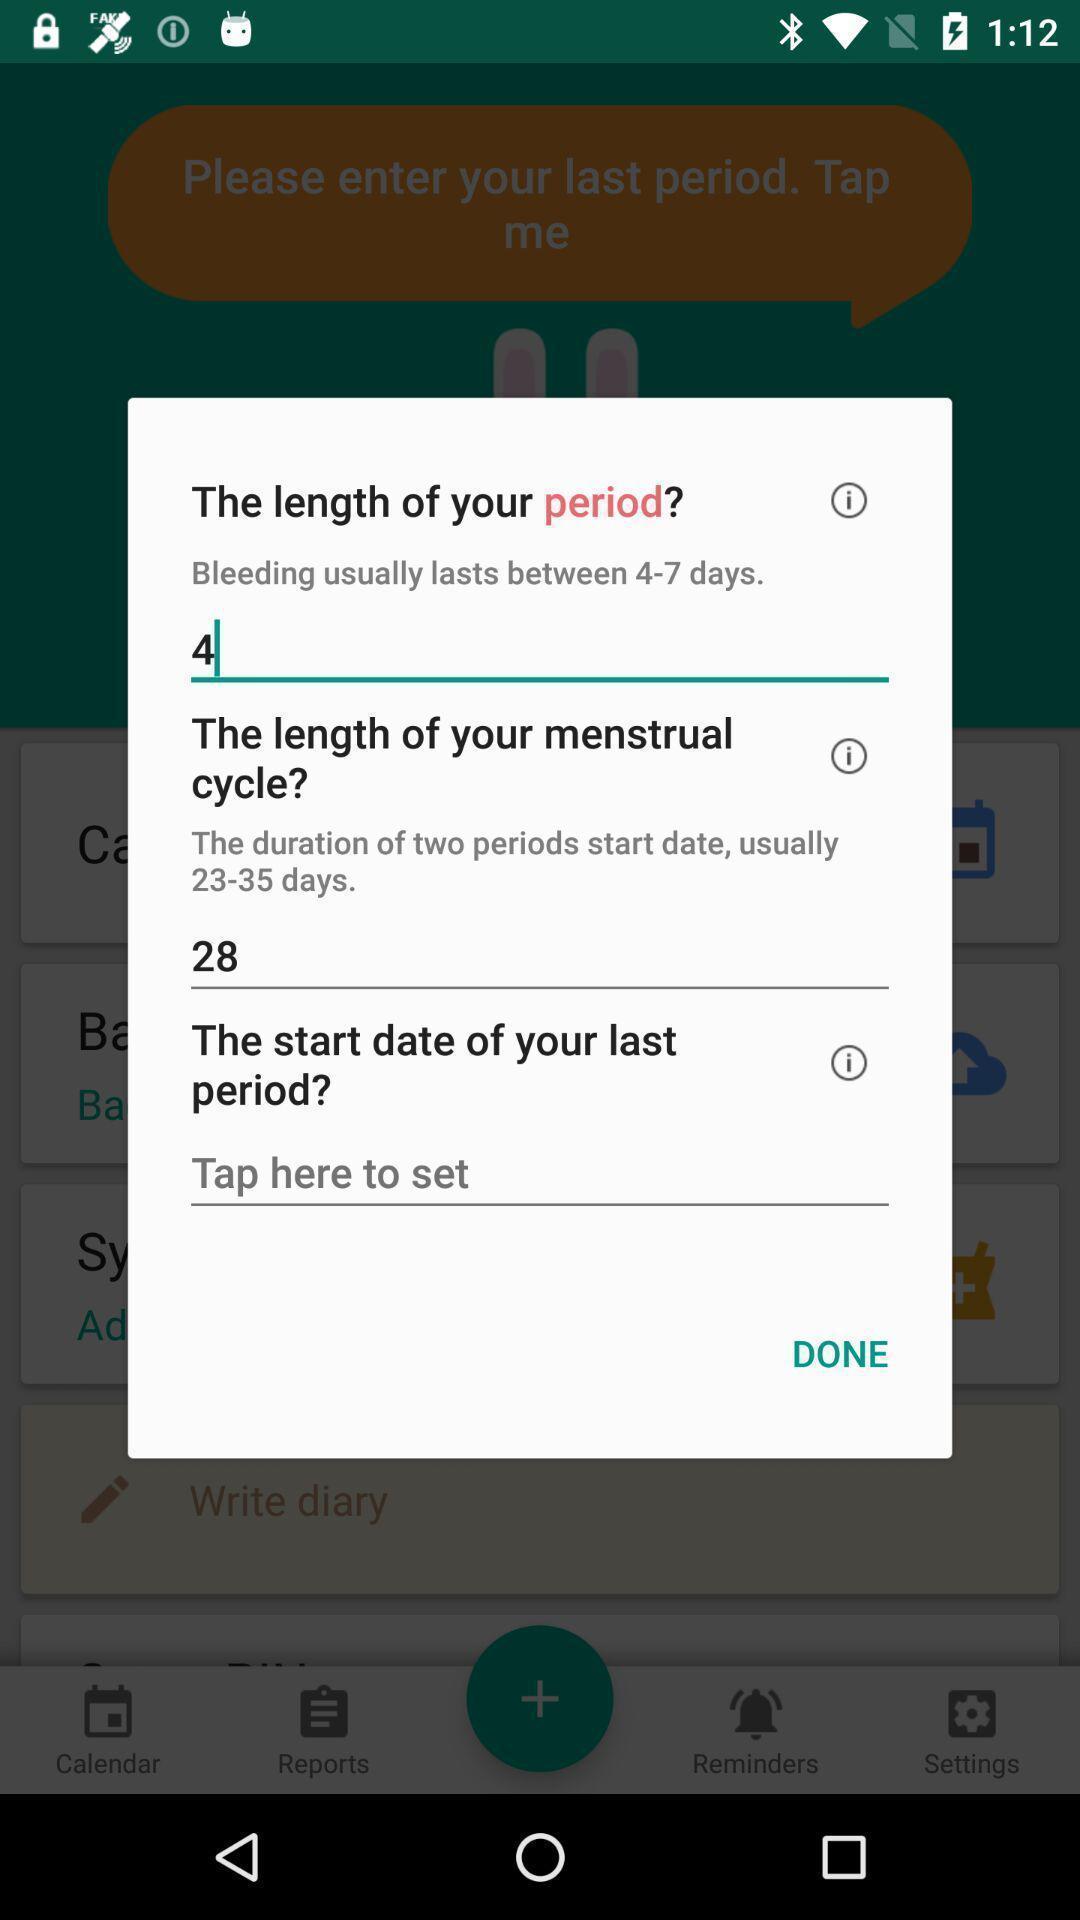Explain the elements present in this screenshot. Pop-up for filling up length of period and menstrual details. 